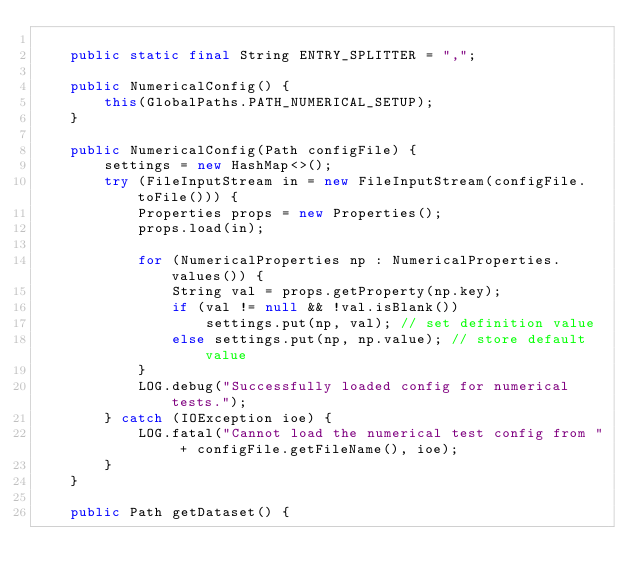<code> <loc_0><loc_0><loc_500><loc_500><_Java_>
    public static final String ENTRY_SPLITTER = ",";

    public NumericalConfig() {
        this(GlobalPaths.PATH_NUMERICAL_SETUP);
    }

    public NumericalConfig(Path configFile) {
        settings = new HashMap<>();
        try (FileInputStream in = new FileInputStream(configFile.toFile())) {
            Properties props = new Properties();
            props.load(in);

            for (NumericalProperties np : NumericalProperties.values()) {
                String val = props.getProperty(np.key);
                if (val != null && !val.isBlank())
                    settings.put(np, val); // set definition value
                else settings.put(np, np.value); // store default value
            }
            LOG.debug("Successfully loaded config for numerical tests.");
        } catch (IOException ioe) {
            LOG.fatal("Cannot load the numerical test config from " + configFile.getFileName(), ioe);
        }
    }

    public Path getDataset() {</code> 